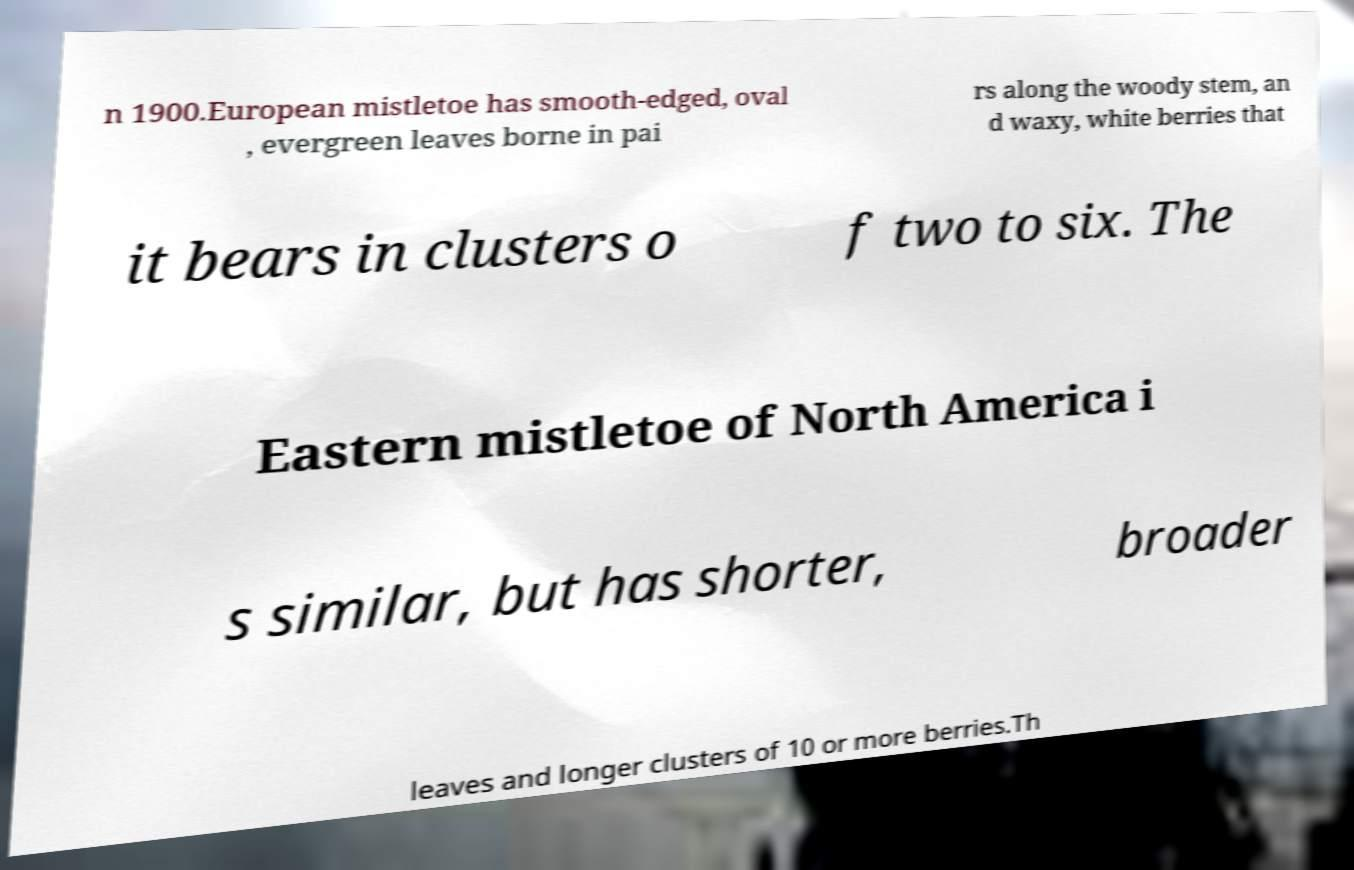There's text embedded in this image that I need extracted. Can you transcribe it verbatim? n 1900.European mistletoe has smooth-edged, oval , evergreen leaves borne in pai rs along the woody stem, an d waxy, white berries that it bears in clusters o f two to six. The Eastern mistletoe of North America i s similar, but has shorter, broader leaves and longer clusters of 10 or more berries.Th 